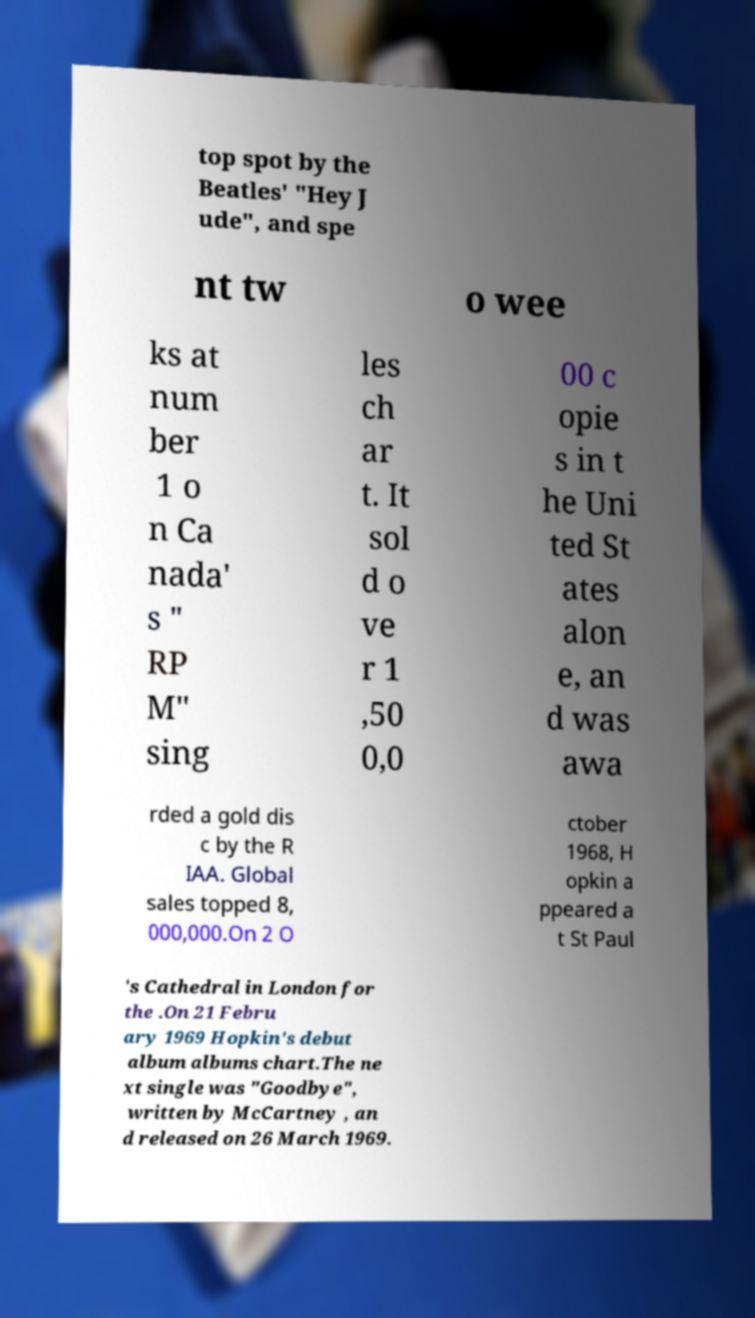What messages or text are displayed in this image? I need them in a readable, typed format. top spot by the Beatles' "Hey J ude", and spe nt tw o wee ks at num ber 1 o n Ca nada' s " RP M" sing les ch ar t. It sol d o ve r 1 ,50 0,0 00 c opie s in t he Uni ted St ates alon e, an d was awa rded a gold dis c by the R IAA. Global sales topped 8, 000,000.On 2 O ctober 1968, H opkin a ppeared a t St Paul 's Cathedral in London for the .On 21 Febru ary 1969 Hopkin's debut album albums chart.The ne xt single was "Goodbye", written by McCartney , an d released on 26 March 1969. 